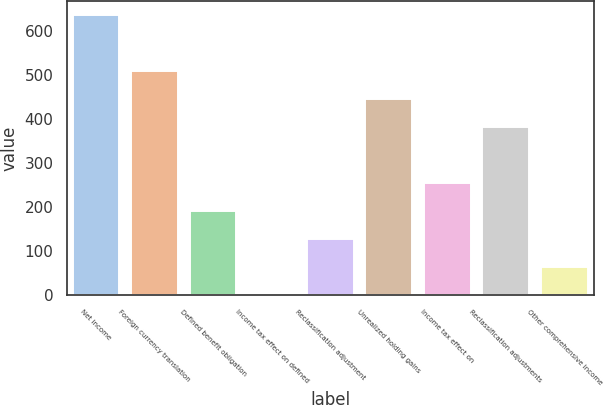<chart> <loc_0><loc_0><loc_500><loc_500><bar_chart><fcel>Net income<fcel>Foreign currency translation<fcel>Defined benefit obligation<fcel>Income tax effect on defined<fcel>Reclassification adjustment<fcel>Unrealized holding gains<fcel>Income tax effect on<fcel>Reclassification adjustments<fcel>Other comprehensive income<nl><fcel>637.5<fcel>510.4<fcel>191.65<fcel>0.4<fcel>127.9<fcel>446.65<fcel>255.4<fcel>382.9<fcel>64.15<nl></chart> 